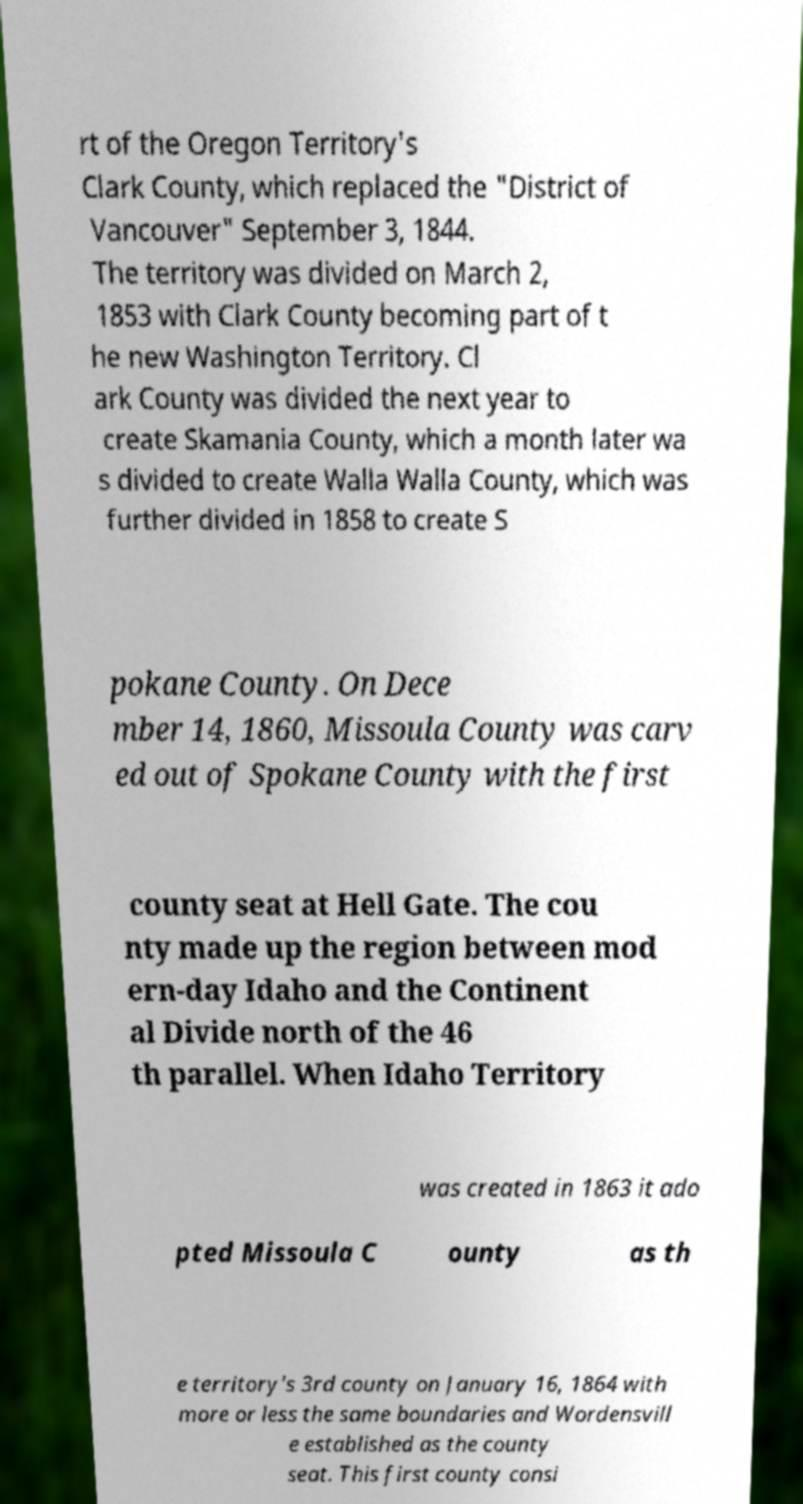Can you read and provide the text displayed in the image?This photo seems to have some interesting text. Can you extract and type it out for me? rt of the Oregon Territory's Clark County, which replaced the "District of Vancouver" September 3, 1844. The territory was divided on March 2, 1853 with Clark County becoming part of t he new Washington Territory. Cl ark County was divided the next year to create Skamania County, which a month later wa s divided to create Walla Walla County, which was further divided in 1858 to create S pokane County. On Dece mber 14, 1860, Missoula County was carv ed out of Spokane County with the first county seat at Hell Gate. The cou nty made up the region between mod ern-day Idaho and the Continent al Divide north of the 46 th parallel. When Idaho Territory was created in 1863 it ado pted Missoula C ounty as th e territory's 3rd county on January 16, 1864 with more or less the same boundaries and Wordensvill e established as the county seat. This first county consi 